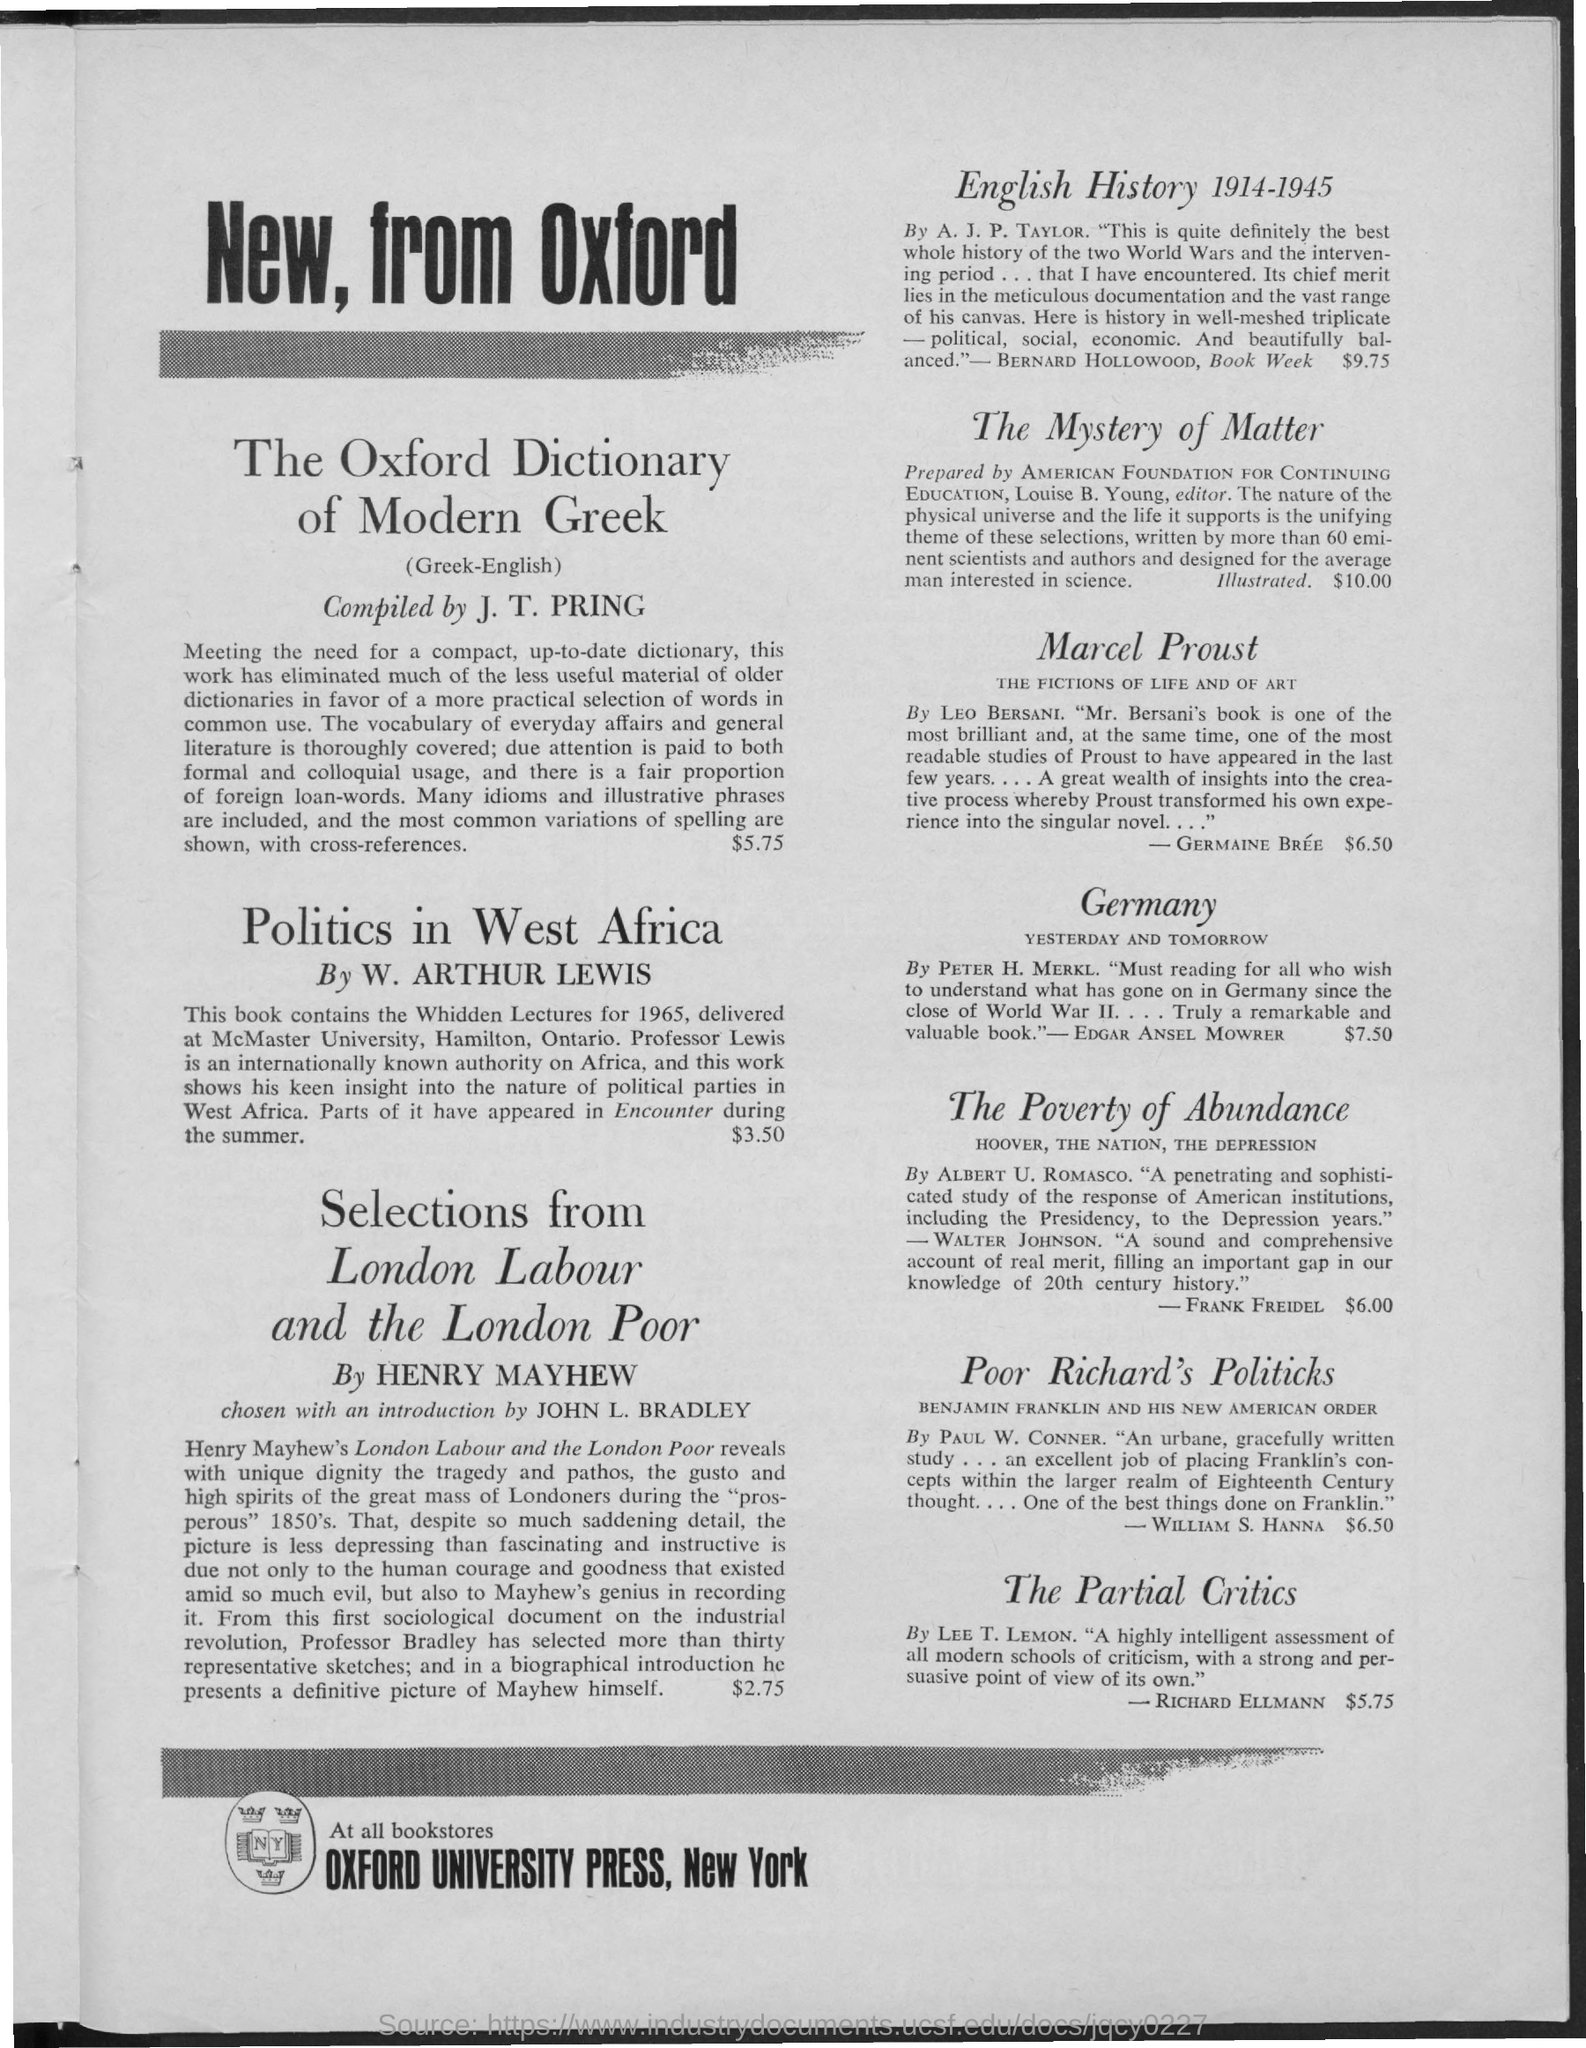Which press is mentioned?
Keep it short and to the point. Oxford University Press. Which dictionary is compiled by J. T. PRING?
Offer a terse response. The Oxford Dictionary of Modern Greek. What is the cost of Politics in West Africa?
Offer a very short reply. $3.50. Who has written English History 1914-1945?
Make the answer very short. A. J. P. Taylor. 